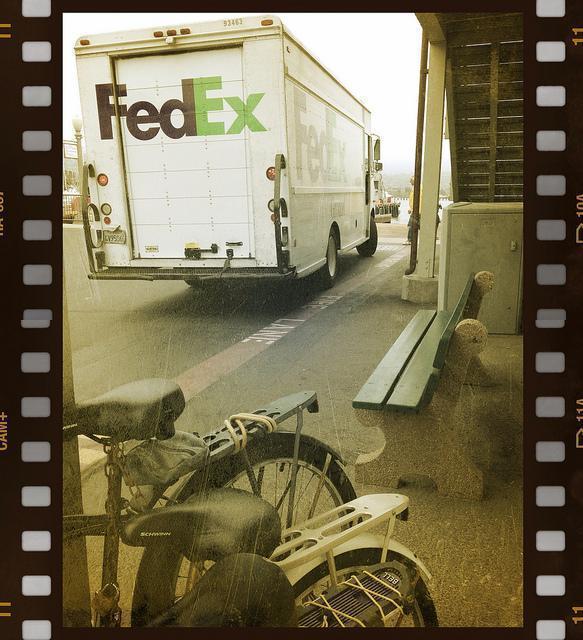What type of business is the truck for?
Pick the correct solution from the four options below to address the question.
Options: Refrigerated items, food truck, delivering packages, gas delivery. Delivering packages. 